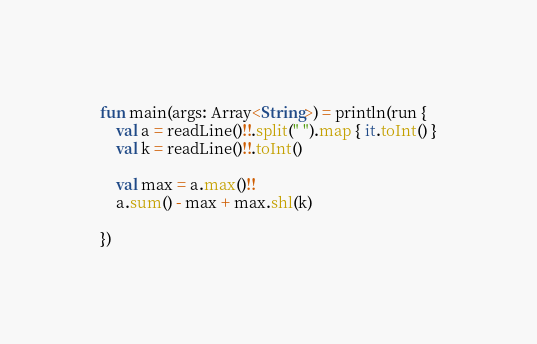<code> <loc_0><loc_0><loc_500><loc_500><_Kotlin_>fun main(args: Array<String>) = println(run {
    val a = readLine()!!.split(" ").map { it.toInt() }
    val k = readLine()!!.toInt()

    val max = a.max()!!
    a.sum() - max + max.shl(k)

})
</code> 